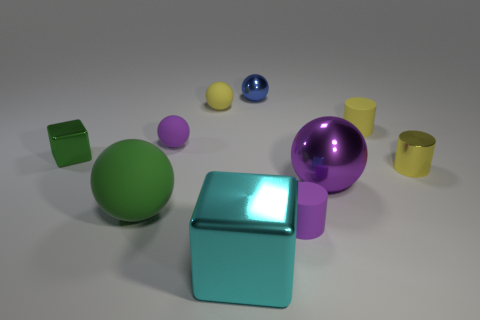There is another metallic thing that is the same shape as the tiny blue shiny thing; what color is it?
Your answer should be compact. Purple. What size is the yellow matte object that is the same shape as the blue metallic thing?
Offer a terse response. Small. Does the small purple matte thing that is left of the large cyan block have the same shape as the small blue metallic thing?
Ensure brevity in your answer.  Yes. What number of large red things are made of the same material as the small green object?
Keep it short and to the point. 0. What color is the other large thing that is the same material as the large cyan thing?
Provide a succinct answer. Purple. Is the green shiny thing the same shape as the cyan shiny object?
Your response must be concise. Yes. There is a sphere that is in front of the large ball that is behind the large green rubber ball; are there any spheres that are right of it?
Your response must be concise. Yes. How many matte cylinders have the same color as the large matte sphere?
Your answer should be very brief. 0. There is a green object that is the same size as the purple shiny ball; what is its shape?
Give a very brief answer. Sphere. There is a tiny yellow shiny cylinder; are there any cubes in front of it?
Your answer should be compact. Yes. 